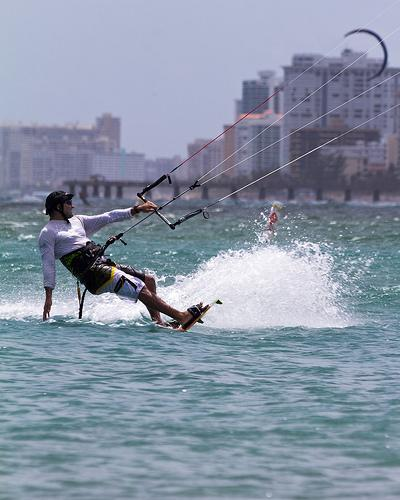What color are the shorts the man is wearing, and do they have any designs on them? The man is wearing white shorts with black and yellow designs. Explain the role of the control lines for the kite and the hand rods in the image. The control lines allow the kiteboarder to control the direction and speed of the kite, while the hand rods help the rider maintain stability and balance while maneuvering through the water. Provide a brief description of the significant objects in the image. A man kitesurfing wearing a black hat, white shirt, and white shorts with black and yellow designs, holding kite rods and attached to a harness, creating a white water wake with his kiteboard while tall buildings stand in the background. Describe the scene in the water around the kite surfer. The water is calm in the foreground, but there is a white water wake formed by the kiteboard as the man glides through, and a red buoy can be seen nearby. Examine the sentiment portrayed by the man and the overall atmosphere of the image. The man appears determined and focused, enjoying the thrill of kitesurfing, and the overall atmosphere of the image is energetic and exciting. Analyze the interactions between various objects and the man in the image. The man is firmly standing on the surfboard, which is kicking up water, while holding the kite rods and being pulled over the water by the kite in the air. His feet are secured by foot straps, and the harness attached to the control lines helps him steer the kite. Provide an estimation of the total number of lines connecting the kite and the man. There are four lines connecting the kite and the man through a belt gear system. Assess the balance and stability of the kite surfer in the image. The man appears to be leaning backward and holding the kite rod with one hand, maintaining balance while being pulled by the kite, and his feet are firmly placed on the surfboard. Describe the look and feel of the water in the image, both near and far. The water appears to be calm in the foreground, while choppy and rough in the distance. Identify any prominent buildings in the background of the image. There are tall city buildings and a brown building in the distance behind the man kitesurfing. Is there a mountain range in the background at X:235 Y:64 with Width:140 and Height:140? No, it's not mentioned in the image. 